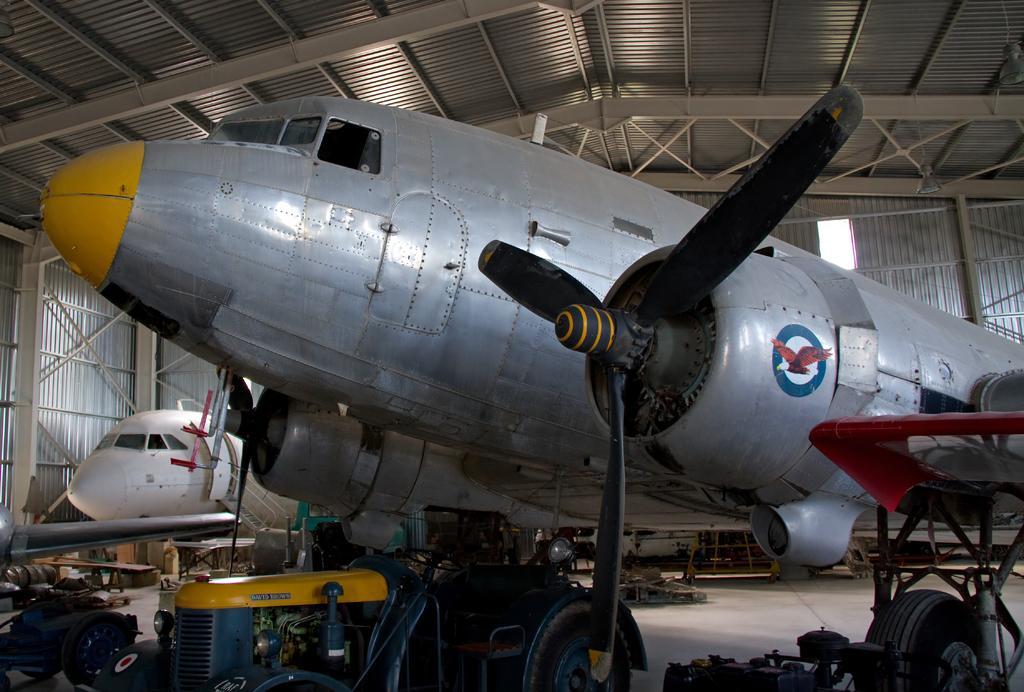How would you summarize this image in a sentence or two? This image is clicked inside a metal shed. There are airplanes in the shed. There are machines and many objects on the floor. There is a picture of an eagle on the airplane. 